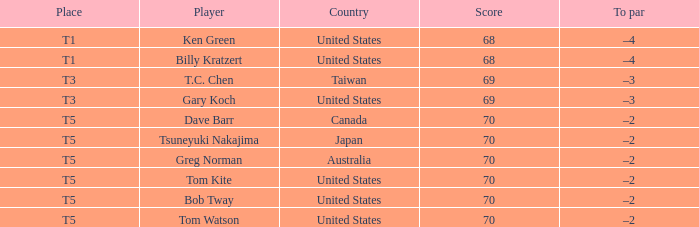Write the full table. {'header': ['Place', 'Player', 'Country', 'Score', 'To par'], 'rows': [['T1', 'Ken Green', 'United States', '68', '–4'], ['T1', 'Billy Kratzert', 'United States', '68', '–4'], ['T3', 'T.C. Chen', 'Taiwan', '69', '–3'], ['T3', 'Gary Koch', 'United States', '69', '–3'], ['T5', 'Dave Barr', 'Canada', '70', '–2'], ['T5', 'Tsuneyuki Nakajima', 'Japan', '70', '–2'], ['T5', 'Greg Norman', 'Australia', '70', '–2'], ['T5', 'Tom Kite', 'United States', '70', '–2'], ['T5', 'Bob Tway', 'United States', '70', '–2'], ['T5', 'Tom Watson', 'United States', '70', '–2']]} What is the lowest point that bob tway got when he placed t5? 70.0. 